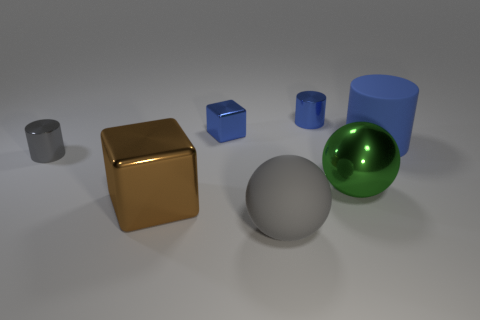There is a small blue object that is the same shape as the gray metal object; what material is it?
Your response must be concise. Metal. Do the big matte cylinder and the small shiny cube have the same color?
Keep it short and to the point. Yes. There is another cylinder that is the same material as the gray cylinder; what is its size?
Offer a very short reply. Small. There is a gray object that is in front of the tiny gray shiny thing; is it the same shape as the tiny gray shiny object?
Your response must be concise. No. The other cylinder that is the same color as the large cylinder is what size?
Offer a very short reply. Small. How many red objects are metallic objects or tiny metallic spheres?
Keep it short and to the point. 0. How many other things are there of the same shape as the large gray rubber object?
Provide a succinct answer. 1. There is a object that is both to the left of the tiny metal cube and behind the brown metallic object; what is its shape?
Your response must be concise. Cylinder. Are there any small gray shiny cylinders on the right side of the large brown block?
Offer a terse response. No. There is another metal thing that is the same shape as the tiny gray shiny thing; what is its size?
Offer a terse response. Small. 